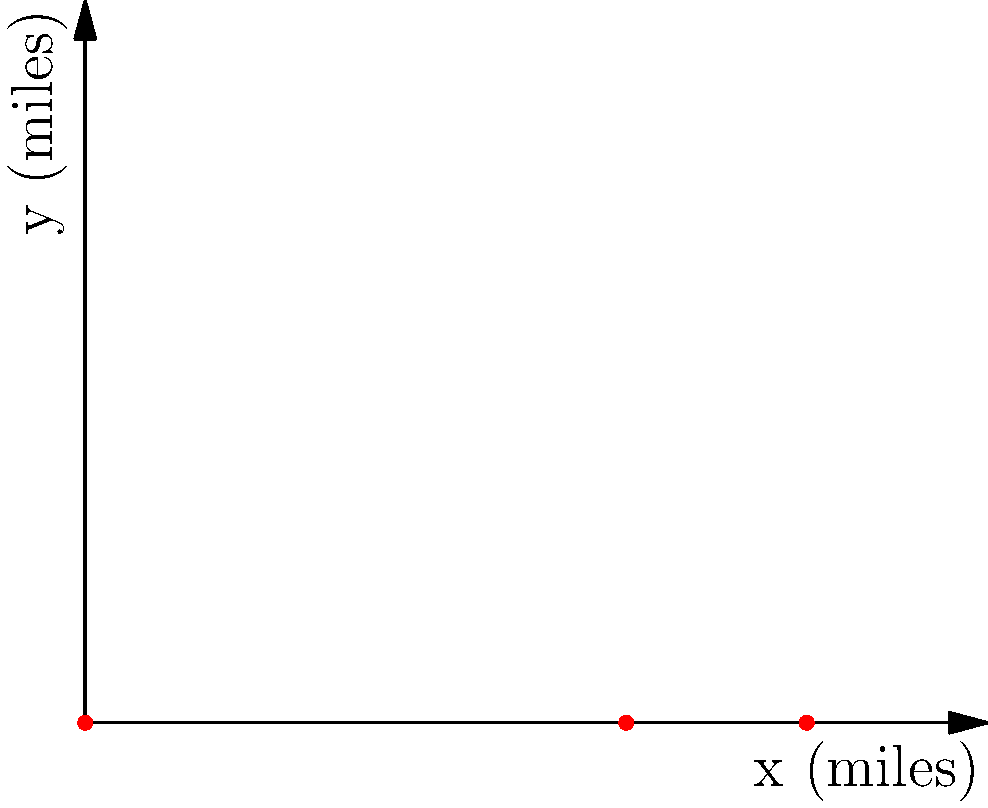On a topographic map used for emergency services planning, two critical points A and B are identified. Point A is at the origin (0, 0) and point B is at coordinates (4, 3), where each unit represents 1 mile. Calculate the direct distance between these two points to determine the quickest emergency response route. To find the distance between two points on a coordinate plane, we can use the distance formula, which is derived from the Pythagorean theorem:

1. The distance formula is:
   $$d = \sqrt{(x_2 - x_1)^2 + (y_2 - y_1)^2}$$

2. We have:
   Point A: $(x_1, y_1) = (0, 0)$
   Point B: $(x_2, y_2) = (4, 3)$

3. Plugging these values into the formula:
   $$d = \sqrt{(4 - 0)^2 + (3 - 0)^2}$$

4. Simplify:
   $$d = \sqrt{4^2 + 3^2}$$

5. Calculate:
   $$d = \sqrt{16 + 9} = \sqrt{25} = 5$$

Therefore, the direct distance between points A and B is 5 miles.
Answer: 5 miles 